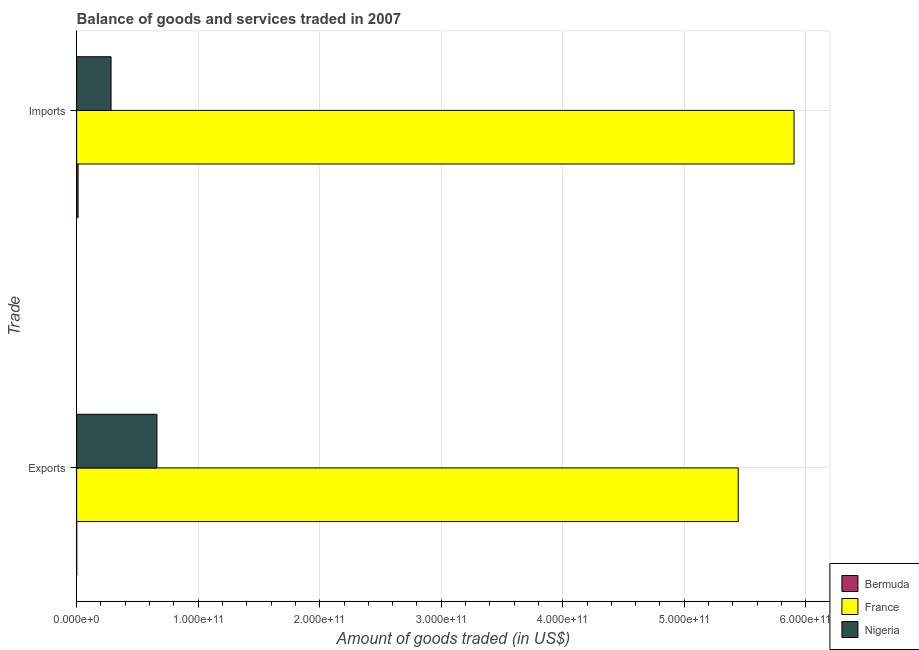How many groups of bars are there?
Your answer should be compact. 2. Are the number of bars on each tick of the Y-axis equal?
Make the answer very short. Yes. How many bars are there on the 2nd tick from the bottom?
Offer a terse response. 3. What is the label of the 2nd group of bars from the top?
Your response must be concise. Exports. What is the amount of goods imported in Nigeria?
Offer a very short reply. 2.83e+1. Across all countries, what is the maximum amount of goods exported?
Your answer should be compact. 5.44e+11. Across all countries, what is the minimum amount of goods exported?
Ensure brevity in your answer.  2.53e+07. In which country was the amount of goods exported minimum?
Provide a short and direct response. Bermuda. What is the total amount of goods imported in the graph?
Provide a short and direct response. 6.20e+11. What is the difference between the amount of goods imported in Nigeria and that in Bermuda?
Keep it short and to the point. 2.71e+1. What is the difference between the amount of goods exported in Nigeria and the amount of goods imported in Bermuda?
Give a very brief answer. 6.49e+1. What is the average amount of goods imported per country?
Offer a terse response. 2.07e+11. What is the difference between the amount of goods exported and amount of goods imported in Nigeria?
Provide a succinct answer. 3.77e+1. In how many countries, is the amount of goods exported greater than 300000000000 US$?
Give a very brief answer. 1. What is the ratio of the amount of goods imported in Nigeria to that in Bermuda?
Offer a very short reply. 24.27. How many bars are there?
Your answer should be compact. 6. Are all the bars in the graph horizontal?
Your answer should be compact. Yes. What is the difference between two consecutive major ticks on the X-axis?
Provide a succinct answer. 1.00e+11. Does the graph contain any zero values?
Give a very brief answer. No. Does the graph contain grids?
Offer a terse response. Yes. How many legend labels are there?
Offer a terse response. 3. What is the title of the graph?
Your response must be concise. Balance of goods and services traded in 2007. What is the label or title of the X-axis?
Provide a succinct answer. Amount of goods traded (in US$). What is the label or title of the Y-axis?
Your response must be concise. Trade. What is the Amount of goods traded (in US$) in Bermuda in Exports?
Your answer should be compact. 2.53e+07. What is the Amount of goods traded (in US$) in France in Exports?
Your response must be concise. 5.44e+11. What is the Amount of goods traded (in US$) of Nigeria in Exports?
Your response must be concise. 6.60e+1. What is the Amount of goods traded (in US$) in Bermuda in Imports?
Provide a short and direct response. 1.17e+09. What is the Amount of goods traded (in US$) of France in Imports?
Ensure brevity in your answer.  5.90e+11. What is the Amount of goods traded (in US$) of Nigeria in Imports?
Make the answer very short. 2.83e+1. Across all Trade, what is the maximum Amount of goods traded (in US$) of Bermuda?
Offer a very short reply. 1.17e+09. Across all Trade, what is the maximum Amount of goods traded (in US$) of France?
Give a very brief answer. 5.90e+11. Across all Trade, what is the maximum Amount of goods traded (in US$) in Nigeria?
Give a very brief answer. 6.60e+1. Across all Trade, what is the minimum Amount of goods traded (in US$) in Bermuda?
Provide a short and direct response. 2.53e+07. Across all Trade, what is the minimum Amount of goods traded (in US$) in France?
Your answer should be compact. 5.44e+11. Across all Trade, what is the minimum Amount of goods traded (in US$) of Nigeria?
Offer a very short reply. 2.83e+1. What is the total Amount of goods traded (in US$) in Bermuda in the graph?
Give a very brief answer. 1.19e+09. What is the total Amount of goods traded (in US$) of France in the graph?
Provide a succinct answer. 1.13e+12. What is the total Amount of goods traded (in US$) of Nigeria in the graph?
Make the answer very short. 9.43e+1. What is the difference between the Amount of goods traded (in US$) in Bermuda in Exports and that in Imports?
Make the answer very short. -1.14e+09. What is the difference between the Amount of goods traded (in US$) of France in Exports and that in Imports?
Make the answer very short. -4.59e+1. What is the difference between the Amount of goods traded (in US$) in Nigeria in Exports and that in Imports?
Your answer should be very brief. 3.77e+1. What is the difference between the Amount of goods traded (in US$) of Bermuda in Exports and the Amount of goods traded (in US$) of France in Imports?
Your response must be concise. -5.90e+11. What is the difference between the Amount of goods traded (in US$) in Bermuda in Exports and the Amount of goods traded (in US$) in Nigeria in Imports?
Provide a succinct answer. -2.83e+1. What is the difference between the Amount of goods traded (in US$) of France in Exports and the Amount of goods traded (in US$) of Nigeria in Imports?
Your answer should be compact. 5.16e+11. What is the average Amount of goods traded (in US$) of Bermuda per Trade?
Your response must be concise. 5.96e+08. What is the average Amount of goods traded (in US$) in France per Trade?
Provide a succinct answer. 5.67e+11. What is the average Amount of goods traded (in US$) in Nigeria per Trade?
Ensure brevity in your answer.  4.72e+1. What is the difference between the Amount of goods traded (in US$) in Bermuda and Amount of goods traded (in US$) in France in Exports?
Offer a very short reply. -5.44e+11. What is the difference between the Amount of goods traded (in US$) in Bermuda and Amount of goods traded (in US$) in Nigeria in Exports?
Your response must be concise. -6.60e+1. What is the difference between the Amount of goods traded (in US$) of France and Amount of goods traded (in US$) of Nigeria in Exports?
Offer a very short reply. 4.78e+11. What is the difference between the Amount of goods traded (in US$) in Bermuda and Amount of goods traded (in US$) in France in Imports?
Your response must be concise. -5.89e+11. What is the difference between the Amount of goods traded (in US$) in Bermuda and Amount of goods traded (in US$) in Nigeria in Imports?
Keep it short and to the point. -2.71e+1. What is the difference between the Amount of goods traded (in US$) in France and Amount of goods traded (in US$) in Nigeria in Imports?
Offer a terse response. 5.62e+11. What is the ratio of the Amount of goods traded (in US$) in Bermuda in Exports to that in Imports?
Give a very brief answer. 0.02. What is the ratio of the Amount of goods traded (in US$) of France in Exports to that in Imports?
Keep it short and to the point. 0.92. What is the ratio of the Amount of goods traded (in US$) of Nigeria in Exports to that in Imports?
Your answer should be very brief. 2.33. What is the difference between the highest and the second highest Amount of goods traded (in US$) in Bermuda?
Your response must be concise. 1.14e+09. What is the difference between the highest and the second highest Amount of goods traded (in US$) of France?
Your response must be concise. 4.59e+1. What is the difference between the highest and the second highest Amount of goods traded (in US$) of Nigeria?
Offer a very short reply. 3.77e+1. What is the difference between the highest and the lowest Amount of goods traded (in US$) in Bermuda?
Give a very brief answer. 1.14e+09. What is the difference between the highest and the lowest Amount of goods traded (in US$) of France?
Make the answer very short. 4.59e+1. What is the difference between the highest and the lowest Amount of goods traded (in US$) in Nigeria?
Your answer should be very brief. 3.77e+1. 